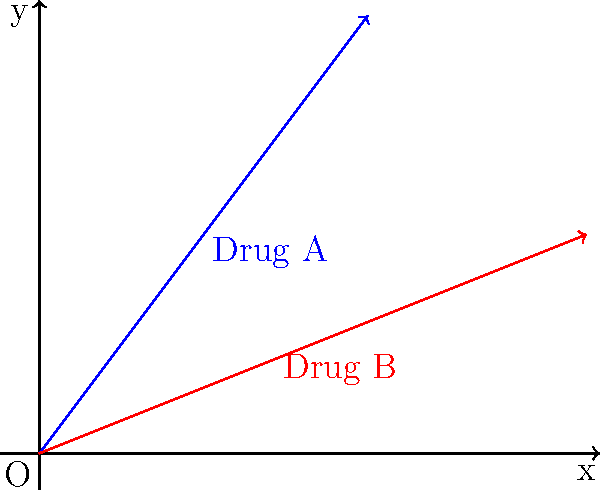In a study comparing two drug dosage regimens, Drug A and Drug B are represented by vectors in a 2D plane. Drug A is represented by the vector (3, 4), and Drug B is represented by the vector (5, 2). What is the angle (in degrees, rounded to the nearest whole number) between these two vectors? To find the angle between two vectors, we can use the dot product formula:

$$\cos \theta = \frac{\mathbf{a} \cdot \mathbf{b}}{|\mathbf{a}||\mathbf{b}|}$$

Where $\mathbf{a}$ and $\mathbf{b}$ are the two vectors, and $\theta$ is the angle between them.

Step 1: Calculate the dot product of the vectors.
$\mathbf{a} \cdot \mathbf{b} = (3 \times 5) + (4 \times 2) = 15 + 8 = 23$

Step 2: Calculate the magnitudes of the vectors.
$|\mathbf{a}| = \sqrt{3^2 + 4^2} = \sqrt{9 + 16} = \sqrt{25} = 5$
$|\mathbf{b}| = \sqrt{5^2 + 2^2} = \sqrt{25 + 4} = \sqrt{29}$

Step 3: Apply the dot product formula.
$$\cos \theta = \frac{23}{5\sqrt{29}}$$

Step 4: Take the inverse cosine (arccos) of both sides.
$$\theta = \arccos\left(\frac{23}{5\sqrt{29}}\right)$$

Step 5: Calculate the result and convert to degrees.
$$\theta \approx 0.4836 \text{ radians}$$
$$\theta \approx 27.71 \text{ degrees}$$

Step 6: Round to the nearest whole number.
$$\theta \approx 28 \text{ degrees}$$
Answer: 28 degrees 